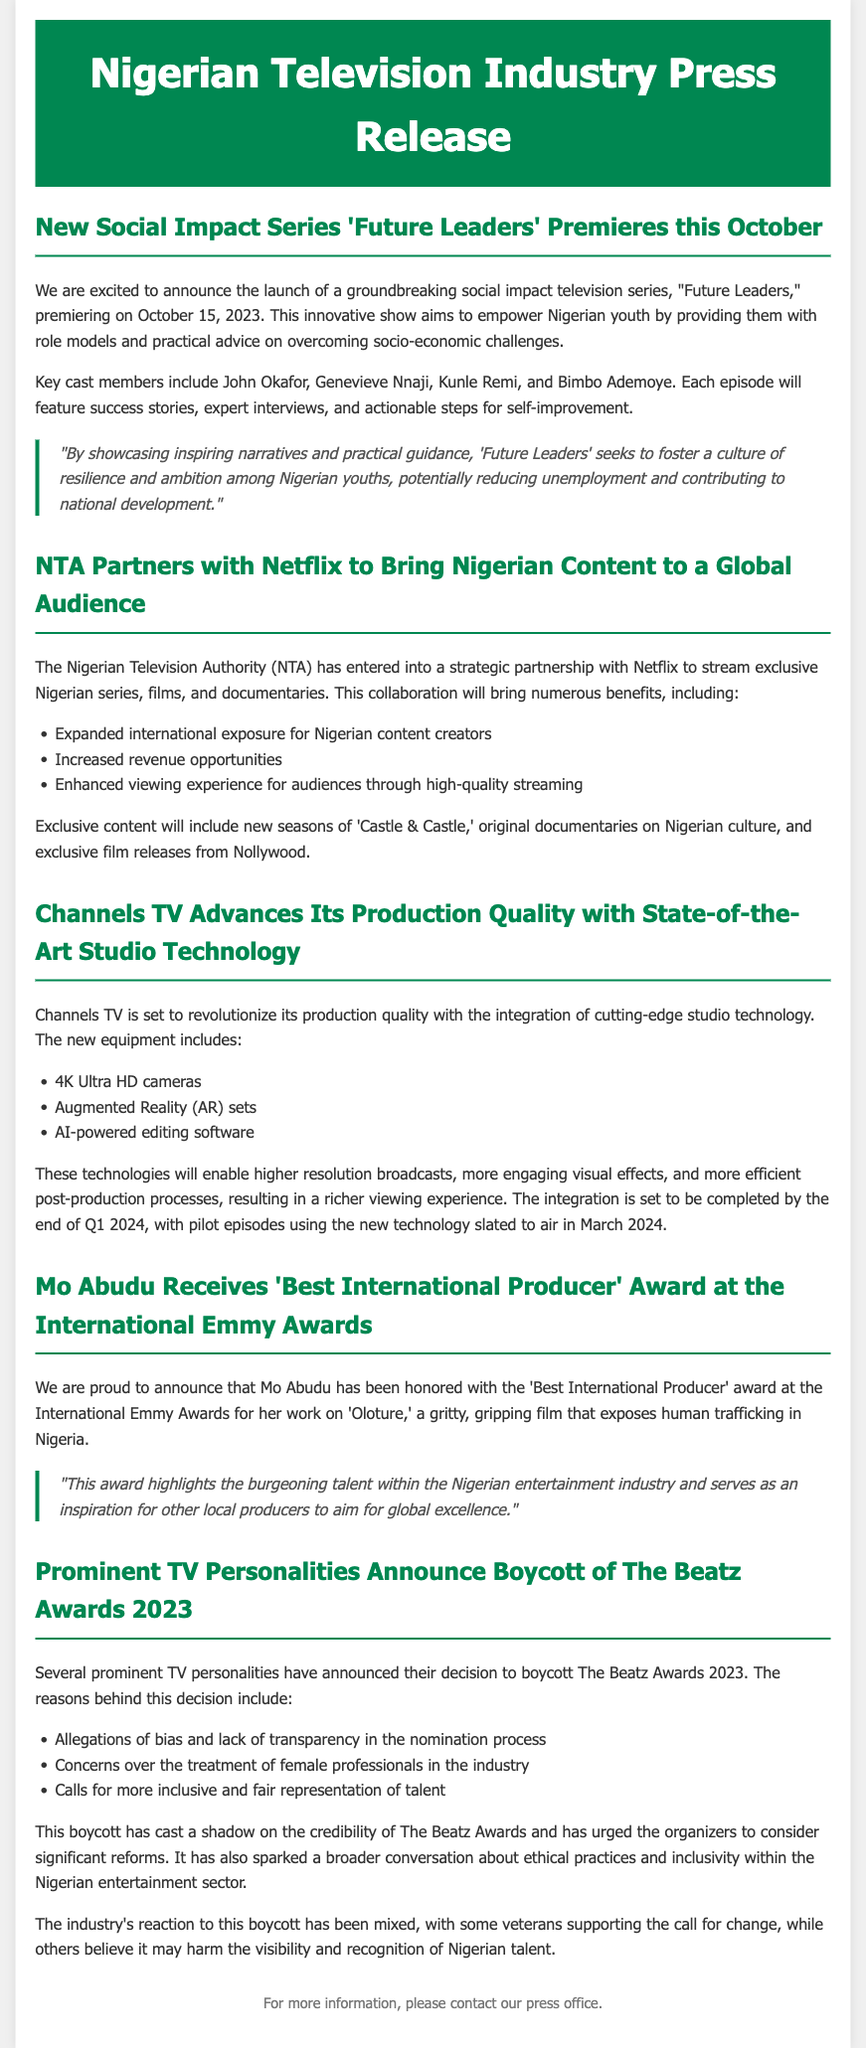What is the premiere date of "Future Leaders"? The premiere date is mentioned in the first section of the document.
Answer: October 15, 2023 Who is one of the key cast members in "Future Leaders"? The document lists the key cast members in the premiere announcement section.
Answer: Genevieve Nnaji What technology will Channels TV integrate by the end of Q1 2024? The document specifies the advanced technology being adopted in Channels TV's production section.
Answer: 4K Ultra HD cameras What award did Mo Abudu win? The document highlights the award received by Mo Abudu in her achievement section.
Answer: Best International Producer What are two reasons for the boycott of The Beatz Awards 2023? The document lists the reasons behind the boycott in the respective section.
Answer: Allegations of bias and lack of transparency What type of series is "Future Leaders"? The document describes the nature of the series in the announcement section.
Answer: Social impact television series What streaming service has partnered with NTA? The partnership details are elaborated in the collaboration section of the document.
Answer: Netflix When will pilot episodes using new technology air? The timeline for the new technology integration is mentioned in the technology section of the document.
Answer: March 2024 Who is the winning project of Mo Abudu associated with? The document refers to the project linked to the award received by Mo Abudu.
Answer: Oloture 